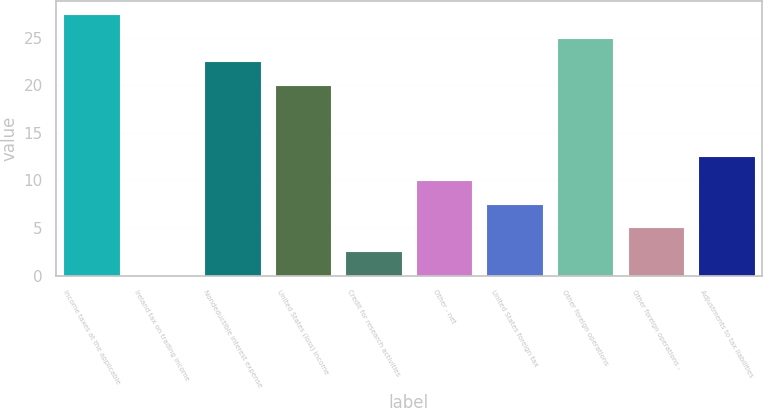Convert chart. <chart><loc_0><loc_0><loc_500><loc_500><bar_chart><fcel>Income taxes at the applicable<fcel>Ireland tax on trading income<fcel>Nondeductible interest expense<fcel>United States (loss) income<fcel>Credit for research activities<fcel>Other - net<fcel>United States foreign tax<fcel>Other foreign operations<fcel>Other foreign operations -<fcel>Adjustments to tax liabilities<nl><fcel>27.49<fcel>0.1<fcel>22.51<fcel>20.02<fcel>2.59<fcel>10.06<fcel>7.57<fcel>25<fcel>5.08<fcel>12.55<nl></chart> 